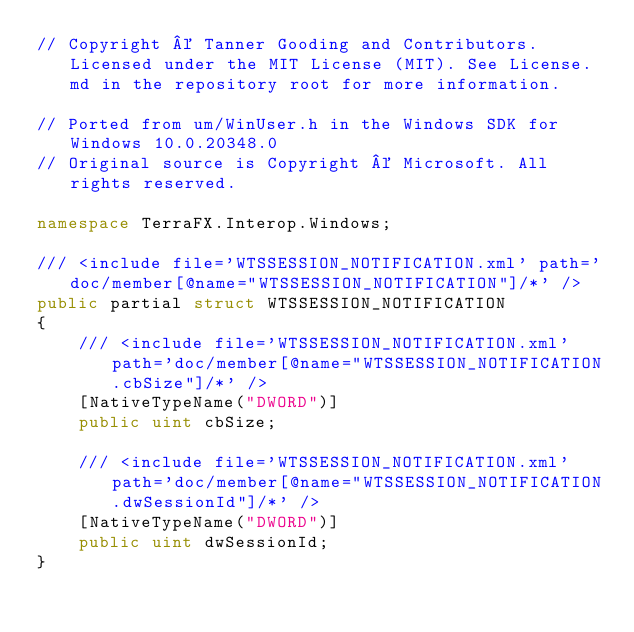Convert code to text. <code><loc_0><loc_0><loc_500><loc_500><_C#_>// Copyright © Tanner Gooding and Contributors. Licensed under the MIT License (MIT). See License.md in the repository root for more information.

// Ported from um/WinUser.h in the Windows SDK for Windows 10.0.20348.0
// Original source is Copyright © Microsoft. All rights reserved.

namespace TerraFX.Interop.Windows;

/// <include file='WTSSESSION_NOTIFICATION.xml' path='doc/member[@name="WTSSESSION_NOTIFICATION"]/*' />
public partial struct WTSSESSION_NOTIFICATION
{
    /// <include file='WTSSESSION_NOTIFICATION.xml' path='doc/member[@name="WTSSESSION_NOTIFICATION.cbSize"]/*' />
    [NativeTypeName("DWORD")]
    public uint cbSize;

    /// <include file='WTSSESSION_NOTIFICATION.xml' path='doc/member[@name="WTSSESSION_NOTIFICATION.dwSessionId"]/*' />
    [NativeTypeName("DWORD")]
    public uint dwSessionId;
}
</code> 